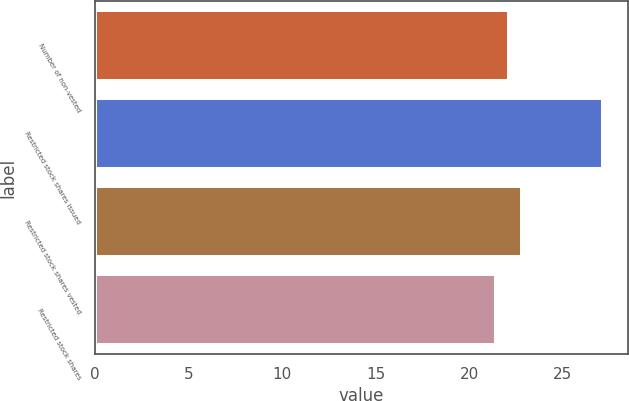Convert chart to OTSL. <chart><loc_0><loc_0><loc_500><loc_500><bar_chart><fcel>Number of non-vested<fcel>Restricted stock shares issued<fcel>Restricted stock shares vested<fcel>Restricted stock shares<nl><fcel>22.13<fcel>27.12<fcel>22.83<fcel>21.43<nl></chart> 